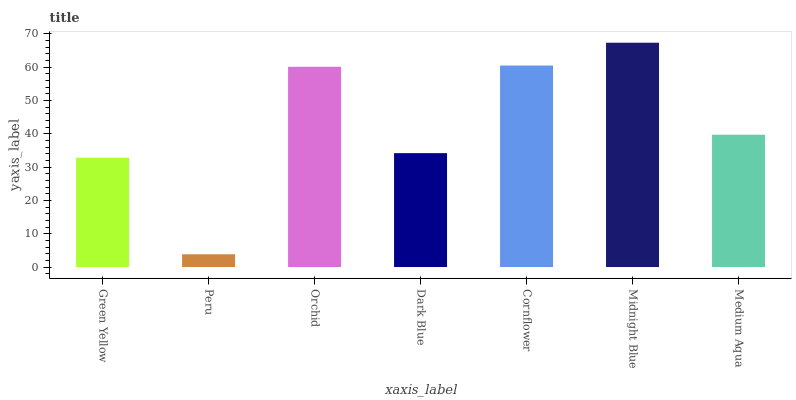Is Peru the minimum?
Answer yes or no. Yes. Is Midnight Blue the maximum?
Answer yes or no. Yes. Is Orchid the minimum?
Answer yes or no. No. Is Orchid the maximum?
Answer yes or no. No. Is Orchid greater than Peru?
Answer yes or no. Yes. Is Peru less than Orchid?
Answer yes or no. Yes. Is Peru greater than Orchid?
Answer yes or no. No. Is Orchid less than Peru?
Answer yes or no. No. Is Medium Aqua the high median?
Answer yes or no. Yes. Is Medium Aqua the low median?
Answer yes or no. Yes. Is Cornflower the high median?
Answer yes or no. No. Is Orchid the low median?
Answer yes or no. No. 